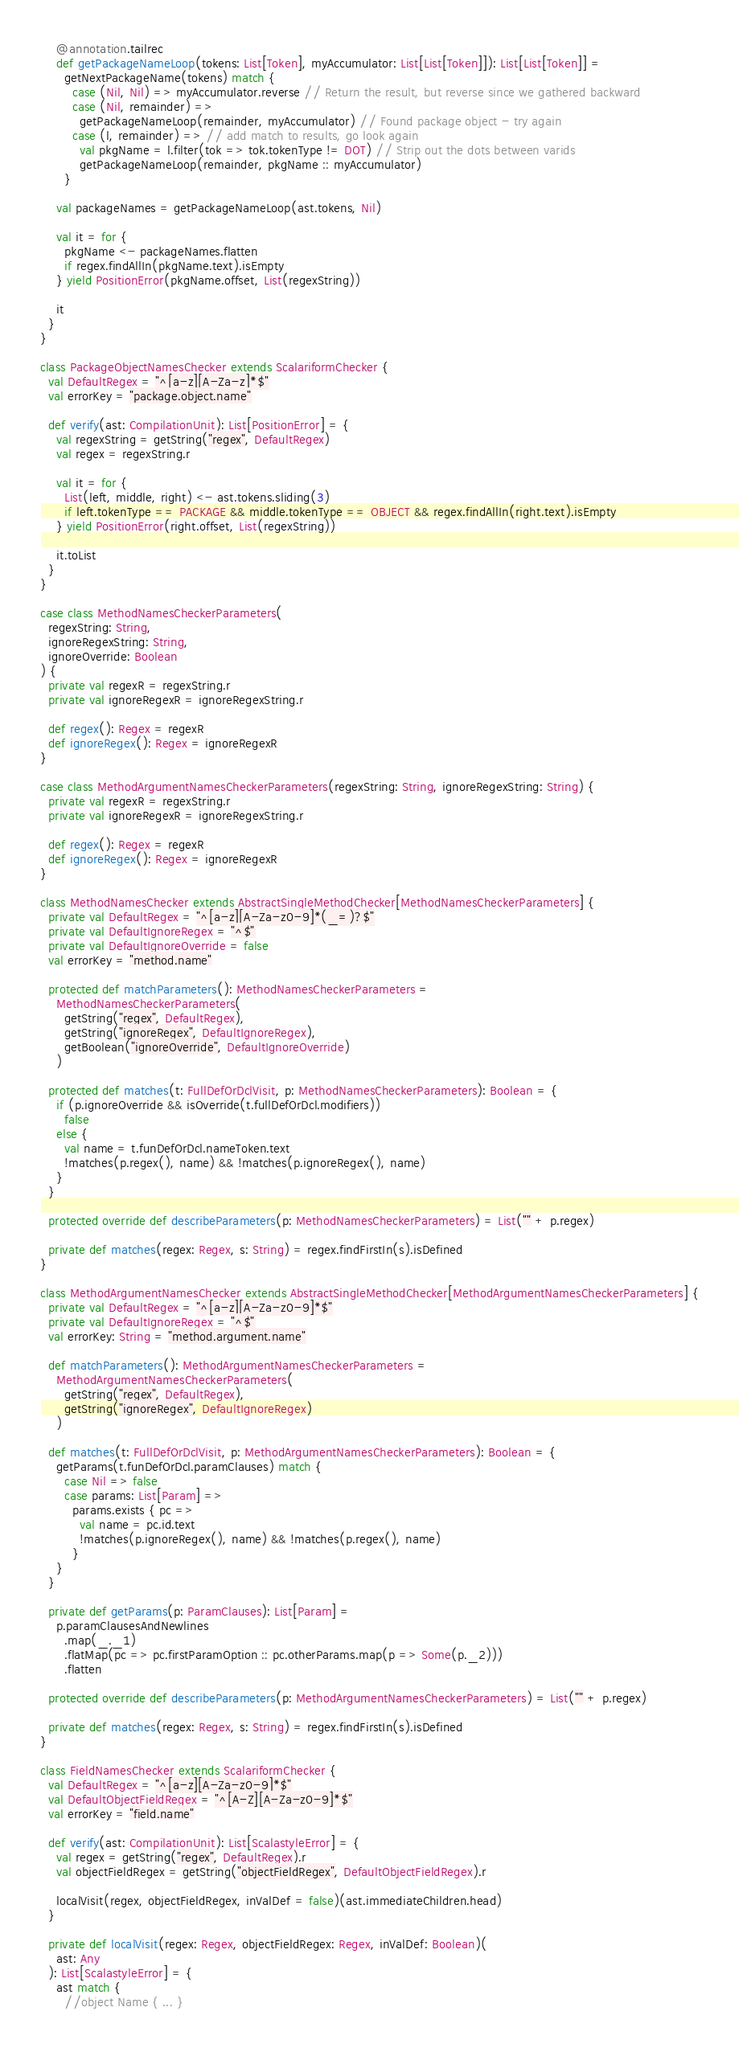Convert code to text. <code><loc_0><loc_0><loc_500><loc_500><_Scala_>    @annotation.tailrec
    def getPackageNameLoop(tokens: List[Token], myAccumulator: List[List[Token]]): List[List[Token]] =
      getNextPackageName(tokens) match {
        case (Nil, Nil) => myAccumulator.reverse // Return the result, but reverse since we gathered backward
        case (Nil, remainder) =>
          getPackageNameLoop(remainder, myAccumulator) // Found package object - try again
        case (l, remainder) => // add match to results, go look again
          val pkgName = l.filter(tok => tok.tokenType != DOT) // Strip out the dots between varids
          getPackageNameLoop(remainder, pkgName :: myAccumulator)
      }

    val packageNames = getPackageNameLoop(ast.tokens, Nil)

    val it = for {
      pkgName <- packageNames.flatten
      if regex.findAllIn(pkgName.text).isEmpty
    } yield PositionError(pkgName.offset, List(regexString))

    it
  }
}

class PackageObjectNamesChecker extends ScalariformChecker {
  val DefaultRegex = "^[a-z][A-Za-z]*$"
  val errorKey = "package.object.name"

  def verify(ast: CompilationUnit): List[PositionError] = {
    val regexString = getString("regex", DefaultRegex)
    val regex = regexString.r

    val it = for {
      List(left, middle, right) <- ast.tokens.sliding(3)
      if left.tokenType == PACKAGE && middle.tokenType == OBJECT && regex.findAllIn(right.text).isEmpty
    } yield PositionError(right.offset, List(regexString))

    it.toList
  }
}

case class MethodNamesCheckerParameters(
  regexString: String,
  ignoreRegexString: String,
  ignoreOverride: Boolean
) {
  private val regexR = regexString.r
  private val ignoreRegexR = ignoreRegexString.r

  def regex(): Regex = regexR
  def ignoreRegex(): Regex = ignoreRegexR
}

case class MethodArgumentNamesCheckerParameters(regexString: String, ignoreRegexString: String) {
  private val regexR = regexString.r
  private val ignoreRegexR = ignoreRegexString.r

  def regex(): Regex = regexR
  def ignoreRegex(): Regex = ignoreRegexR
}

class MethodNamesChecker extends AbstractSingleMethodChecker[MethodNamesCheckerParameters] {
  private val DefaultRegex = "^[a-z][A-Za-z0-9]*(_=)?$"
  private val DefaultIgnoreRegex = "^$"
  private val DefaultIgnoreOverride = false
  val errorKey = "method.name"

  protected def matchParameters(): MethodNamesCheckerParameters =
    MethodNamesCheckerParameters(
      getString("regex", DefaultRegex),
      getString("ignoreRegex", DefaultIgnoreRegex),
      getBoolean("ignoreOverride", DefaultIgnoreOverride)
    )

  protected def matches(t: FullDefOrDclVisit, p: MethodNamesCheckerParameters): Boolean = {
    if (p.ignoreOverride && isOverride(t.fullDefOrDcl.modifiers))
      false
    else {
      val name = t.funDefOrDcl.nameToken.text
      !matches(p.regex(), name) && !matches(p.ignoreRegex(), name)
    }
  }

  protected override def describeParameters(p: MethodNamesCheckerParameters) = List("" + p.regex)

  private def matches(regex: Regex, s: String) = regex.findFirstIn(s).isDefined
}

class MethodArgumentNamesChecker extends AbstractSingleMethodChecker[MethodArgumentNamesCheckerParameters] {
  private val DefaultRegex = "^[a-z][A-Za-z0-9]*$"
  private val DefaultIgnoreRegex = "^$"
  val errorKey: String = "method.argument.name"

  def matchParameters(): MethodArgumentNamesCheckerParameters =
    MethodArgumentNamesCheckerParameters(
      getString("regex", DefaultRegex),
      getString("ignoreRegex", DefaultIgnoreRegex)
    )

  def matches(t: FullDefOrDclVisit, p: MethodArgumentNamesCheckerParameters): Boolean = {
    getParams(t.funDefOrDcl.paramClauses) match {
      case Nil => false
      case params: List[Param] =>
        params.exists { pc =>
          val name = pc.id.text
          !matches(p.ignoreRegex(), name) && !matches(p.regex(), name)
        }
    }
  }

  private def getParams(p: ParamClauses): List[Param] =
    p.paramClausesAndNewlines
      .map(_._1)
      .flatMap(pc => pc.firstParamOption :: pc.otherParams.map(p => Some(p._2)))
      .flatten

  protected override def describeParameters(p: MethodArgumentNamesCheckerParameters) = List("" + p.regex)

  private def matches(regex: Regex, s: String) = regex.findFirstIn(s).isDefined
}

class FieldNamesChecker extends ScalariformChecker {
  val DefaultRegex = "^[a-z][A-Za-z0-9]*$"
  val DefaultObjectFieldRegex = "^[A-Z][A-Za-z0-9]*$"
  val errorKey = "field.name"

  def verify(ast: CompilationUnit): List[ScalastyleError] = {
    val regex = getString("regex", DefaultRegex).r
    val objectFieldRegex = getString("objectFieldRegex", DefaultObjectFieldRegex).r

    localVisit(regex, objectFieldRegex, inValDef = false)(ast.immediateChildren.head)
  }

  private def localVisit(regex: Regex, objectFieldRegex: Regex, inValDef: Boolean)(
    ast: Any
  ): List[ScalastyleError] = {
    ast match {
      //object Name { ... }</code> 